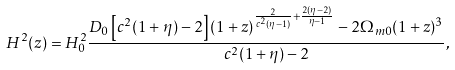Convert formula to latex. <formula><loc_0><loc_0><loc_500><loc_500>H ^ { 2 } ( z ) = H ^ { 2 } _ { 0 } \frac { D _ { 0 } \left [ c ^ { 2 } ( 1 + \eta ) - 2 \right ] ( 1 + z ) ^ { \frac { 2 } { c ^ { 2 } ( \eta - 1 ) } + \frac { 2 ( \eta - 2 ) } { \eta - 1 } } - 2 \Omega _ { m 0 } ( 1 + z ) ^ { 3 } } { c ^ { 2 } ( 1 + \eta ) - 2 } ,</formula> 